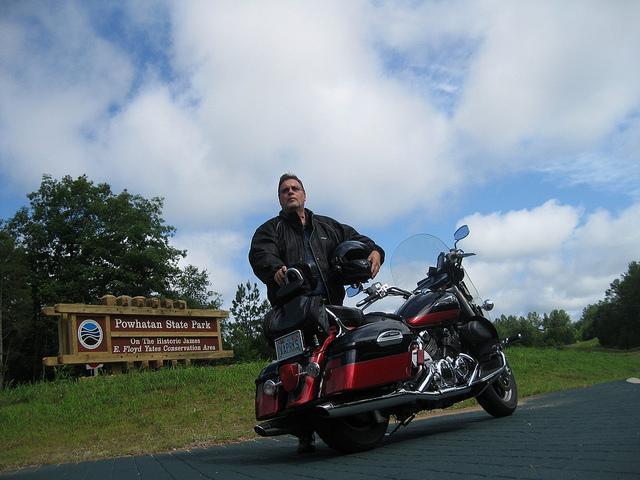How many bikes are there?
Give a very brief answer. 1. How many bikes are in the picture?
Give a very brief answer. 1. How many men are shown?
Give a very brief answer. 1. How many bike are here?
Give a very brief answer. 1. How many bikes in the shot?
Give a very brief answer. 1. How many different kinds of two wheeled transportation are depicted in the photo?
Give a very brief answer. 1. How many motorcycles are there?
Give a very brief answer. 1. How many people are holding book in their hand ?
Give a very brief answer. 0. 